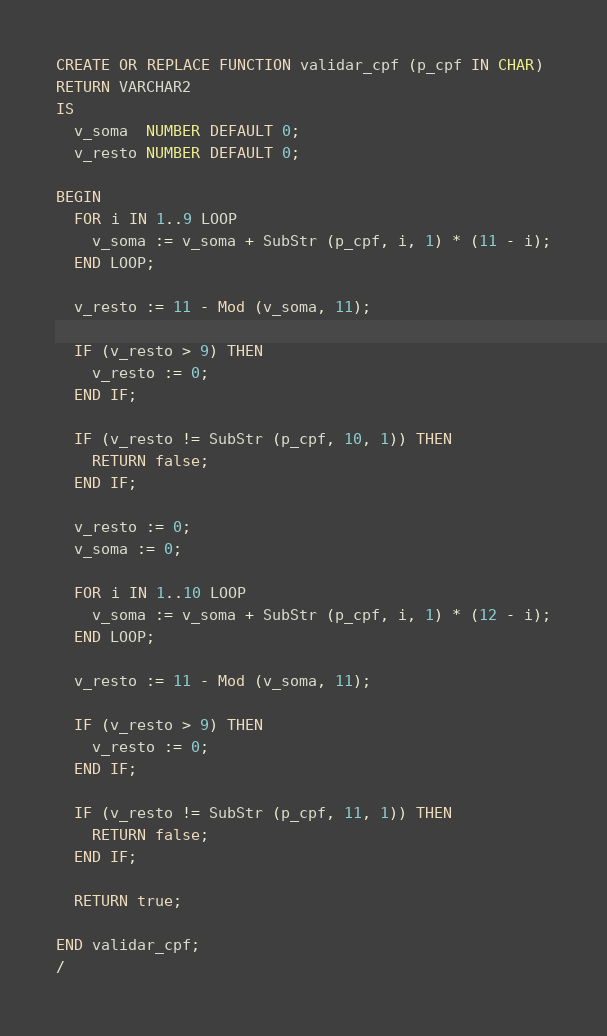<code> <loc_0><loc_0><loc_500><loc_500><_SQL_>CREATE OR REPLACE FUNCTION validar_cpf (p_cpf IN CHAR)
RETURN VARCHAR2
IS
  v_soma  NUMBER DEFAULT 0;
  v_resto NUMBER DEFAULT 0;

BEGIN
  FOR i IN 1..9 LOOP
    v_soma := v_soma + SubStr (p_cpf, i, 1) * (11 - i);
  END LOOP;

  v_resto := 11 - Mod (v_soma, 11);

  IF (v_resto > 9) THEN
    v_resto := 0;
  END IF;

  IF (v_resto != SubStr (p_cpf, 10, 1)) THEN
    RETURN false;
  END IF;

  v_resto := 0;
  v_soma := 0;

  FOR i IN 1..10 LOOP
    v_soma := v_soma + SubStr (p_cpf, i, 1) * (12 - i);
  END LOOP;

  v_resto := 11 - Mod (v_soma, 11);

  IF (v_resto > 9) THEN
    v_resto := 0;
  END IF;

  IF (v_resto != SubStr (p_cpf, 11, 1)) THEN
    RETURN false;
  END IF;

  RETURN true;

END validar_cpf;
/
</code> 